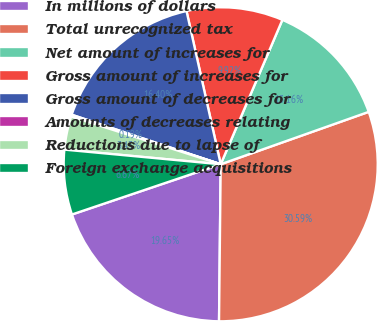Convert chart to OTSL. <chart><loc_0><loc_0><loc_500><loc_500><pie_chart><fcel>In millions of dollars<fcel>Total unrecognized tax<fcel>Net amount of increases for<fcel>Gross amount of increases for<fcel>Gross amount of decreases for<fcel>Amounts of decreases relating<fcel>Reductions due to lapse of<fcel>Foreign exchange acquisitions<nl><fcel>19.65%<fcel>30.59%<fcel>13.16%<fcel>9.92%<fcel>16.4%<fcel>0.19%<fcel>3.43%<fcel>6.67%<nl></chart> 